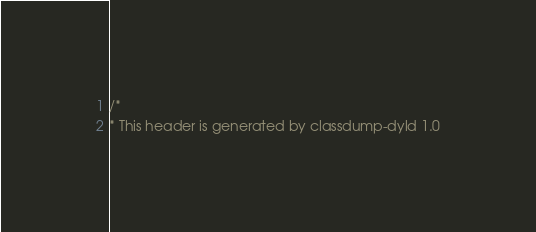<code> <loc_0><loc_0><loc_500><loc_500><_C_>/*
* This header is generated by classdump-dyld 1.0</code> 